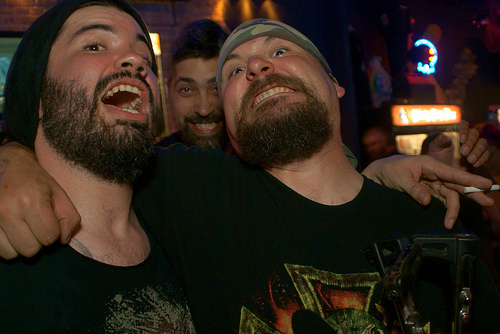<image>
Is there a surprised man in front of the grinning man? Yes. The surprised man is positioned in front of the grinning man, appearing closer to the camera viewpoint. 